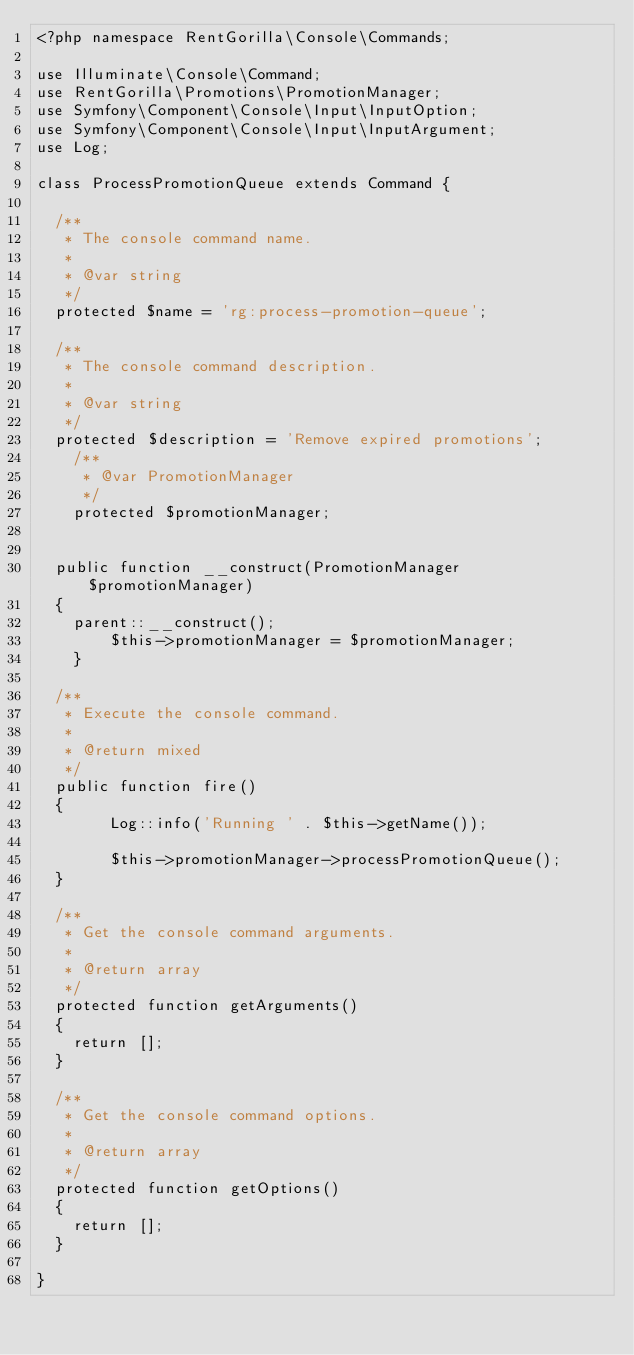Convert code to text. <code><loc_0><loc_0><loc_500><loc_500><_PHP_><?php namespace RentGorilla\Console\Commands;

use Illuminate\Console\Command;
use RentGorilla\Promotions\PromotionManager;
use Symfony\Component\Console\Input\InputOption;
use Symfony\Component\Console\Input\InputArgument;
use Log;

class ProcessPromotionQueue extends Command {

	/**
	 * The console command name.
	 *
	 * @var string
	 */
	protected $name = 'rg:process-promotion-queue';

	/**
	 * The console command description.
	 *
	 * @var string
	 */
	protected $description = 'Remove expired promotions';
    /**
     * @var PromotionManager
     */
    protected $promotionManager;


	public function __construct(PromotionManager $promotionManager)
	{
		parent::__construct();
        $this->promotionManager = $promotionManager;
    }

	/**
	 * Execute the console command.
	 *
	 * @return mixed
	 */
	public function fire()
	{
        Log::info('Running ' . $this->getName());

        $this->promotionManager->processPromotionQueue();
	}

	/**
	 * Get the console command arguments.
	 *
	 * @return array
	 */
	protected function getArguments()
	{
		return [];
	}

	/**
	 * Get the console command options.
	 *
	 * @return array
	 */
	protected function getOptions()
	{
		return [];
	}

}
</code> 